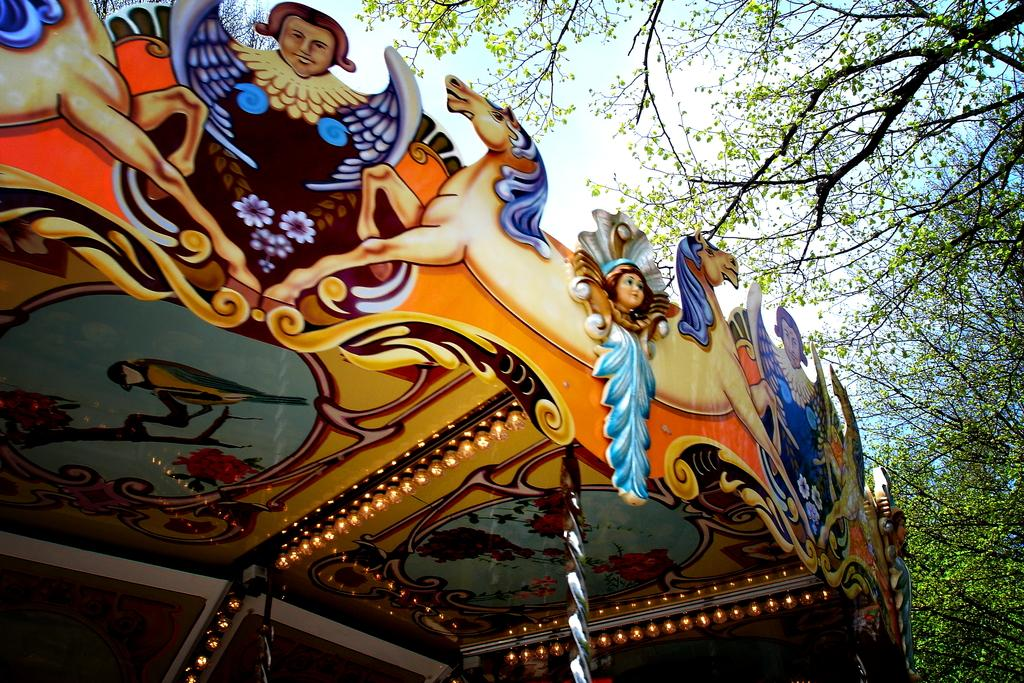What is featured on the ceiling in the image? There is a ceiling with colorful lights in the image. Are there any decorations on the ceiling? Yes, there are paintings on the ceiling. What can be seen on the right side of the image? There are trees on the right side of the image. What force is acting on the paintings on the ceiling? There is no mention of a force acting on the paintings on the ceiling. --- Facts: 1. There is a person in the image. 2. The person is wearing a hat. 3. The person is holding a book. Absurd Topics: parrot, piano, Conversation: Who or what is present in the image? There is a person in the image. What is the person wearing in the image? The person is wearing a hat in the image. What is the person holding in the image? The person is holding a book in the image. Reasoning: Let's think step by step in order to create the conversation. We start by identifying the main subject of the image, which is the person. Then, we describe specific features of the person, such as the hat and the book they are holding. By doing this, we ensure that each question can be answered definitively with the information given. We avoid yes/no questions and ensure that the language is simple and clear. Absurd Question/Answer: Can you hear the parrot singing in the image? There is no mention of a parrot in the image, so it is not possible to determine if a parrot is singing. --- Facts: 1. There is a group of people in the image. 2. The people are sitting on a bench. 3. There is a park in the background of the image. Absurd Topics: elephant, trampoline, Conversation: How many people are present in the image? There is a group of people in the image. What are the people doing in the image? The people are sitting on a bench in the image. What can be seen in the background of the image? There is a park in the background of the image. Reasoning: Let's think step by step in order to create the conversation. We start by identifying the main subject of the image, which is the group of people. Then, we describe the specific action of the people, which is sitting on a bench. Finally, we describe the background of the image, which is a park. By doing this, we ensure that each question can be answered definitively with the information given. We avoid yes/no questions and ensure that the language is simple and clear. Absurd Question/Answer: Where is the trampoline located in the image? There is no mention of a trampoline in the image, so it is not possible to determine its location. --- Facts: 1. There is a car in the image. 2. 